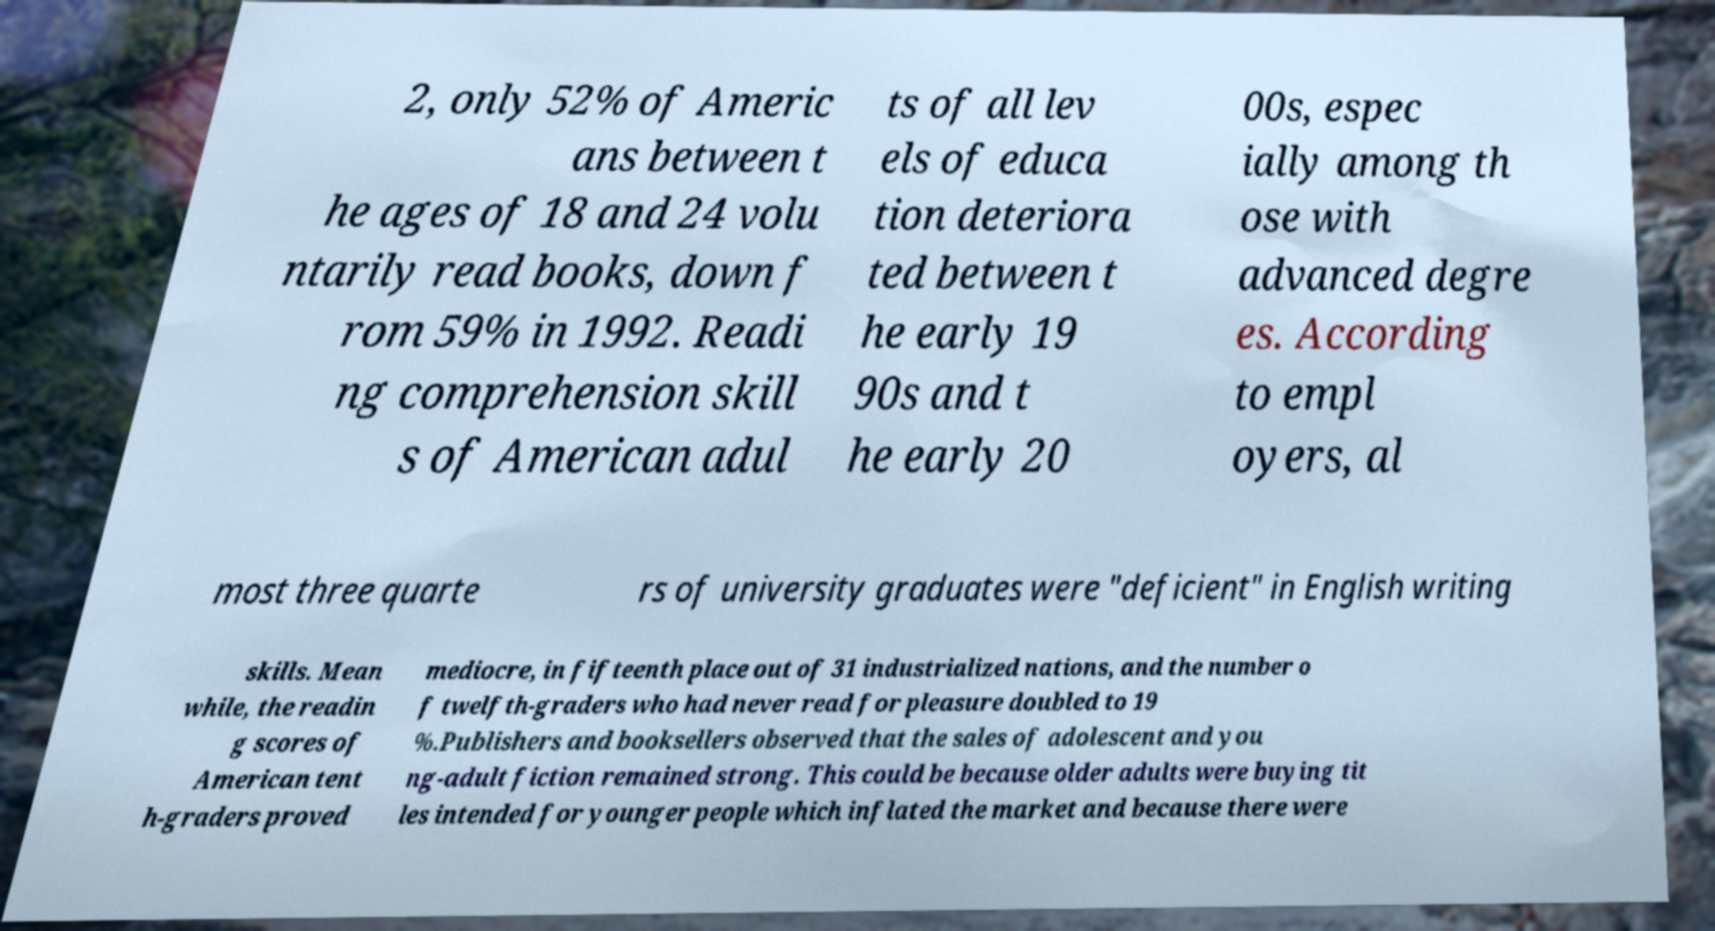There's text embedded in this image that I need extracted. Can you transcribe it verbatim? 2, only 52% of Americ ans between t he ages of 18 and 24 volu ntarily read books, down f rom 59% in 1992. Readi ng comprehension skill s of American adul ts of all lev els of educa tion deteriora ted between t he early 19 90s and t he early 20 00s, espec ially among th ose with advanced degre es. According to empl oyers, al most three quarte rs of university graduates were "deficient" in English writing skills. Mean while, the readin g scores of American tent h-graders proved mediocre, in fifteenth place out of 31 industrialized nations, and the number o f twelfth-graders who had never read for pleasure doubled to 19 %.Publishers and booksellers observed that the sales of adolescent and you ng-adult fiction remained strong. This could be because older adults were buying tit les intended for younger people which inflated the market and because there were 